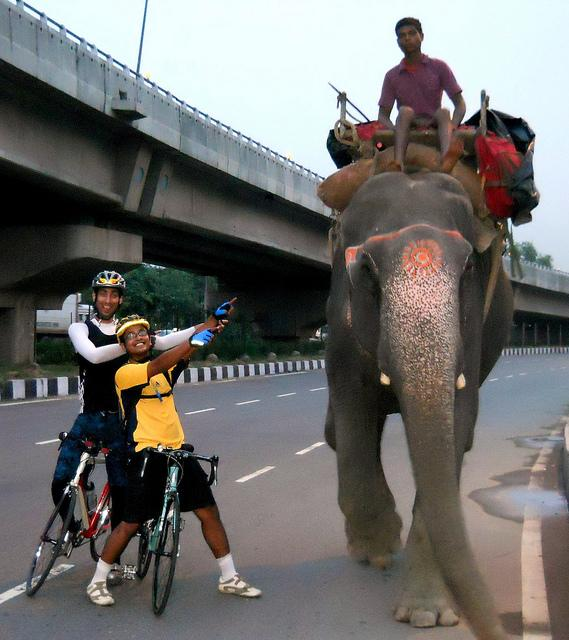What are the helmets shells made from?

Choices:
A) plastic
B) steel
C) foam
D) clay plastic 